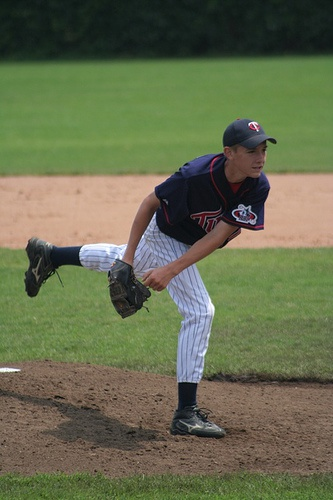Describe the objects in this image and their specific colors. I can see people in black, gray, and darkgray tones and baseball glove in black, gray, darkgreen, and purple tones in this image. 